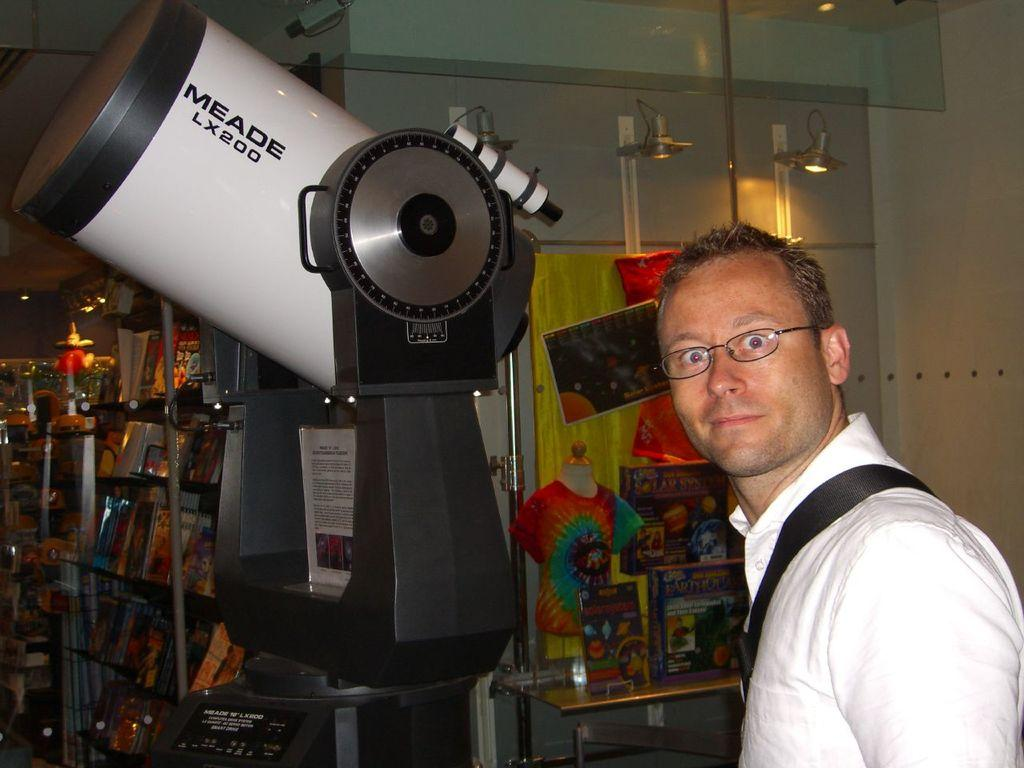Who is present in the image? There is a man in the image. What is the man wearing? The man is wearing spectacles. What can be seen in the image besides the man? There is a telescope, boards, books, lights, and other objects in the image. What type of beef is being prepared in the image? There is no beef present in the image; it features a man with spectacles, a telescope, boards, books, lights, and other objects. What month is it in the image? The image does not provide any information about the month; it only shows a man with spectacles, a telescope, boards, books, lights, and other objects. 